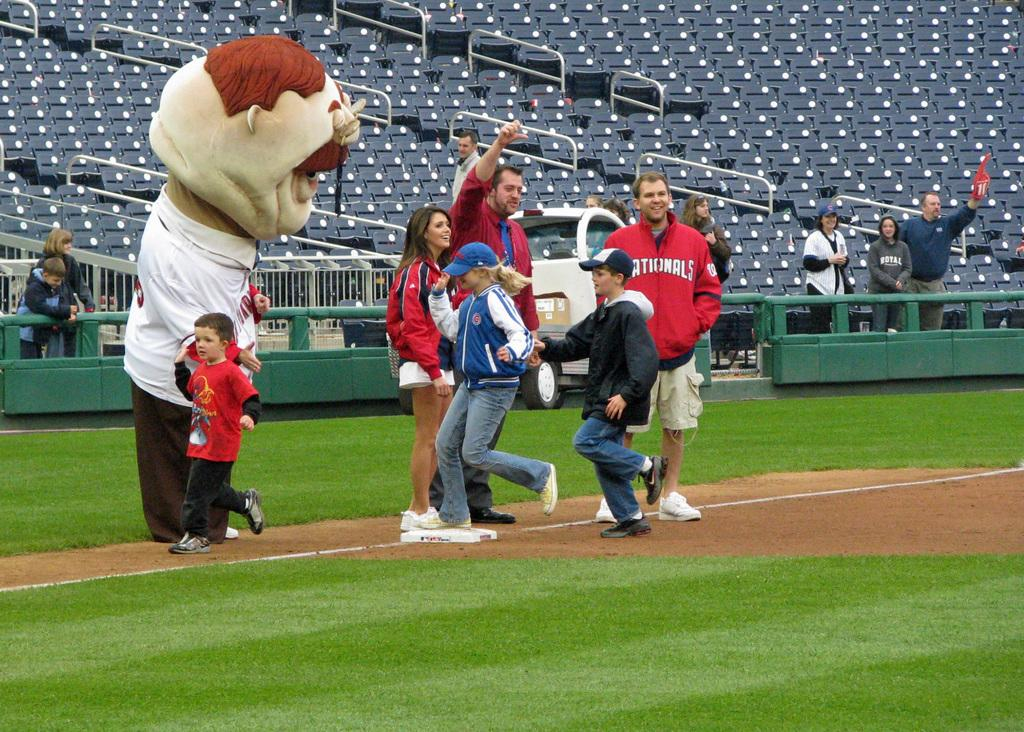Provide a one-sentence caption for the provided image. A group of people, a mascot and a man wearing a Cardinals jacket. 